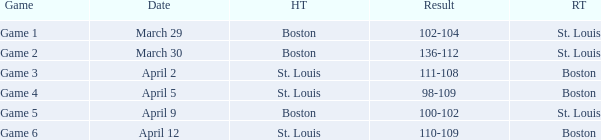What is the Result of Game 3? 111-108. 